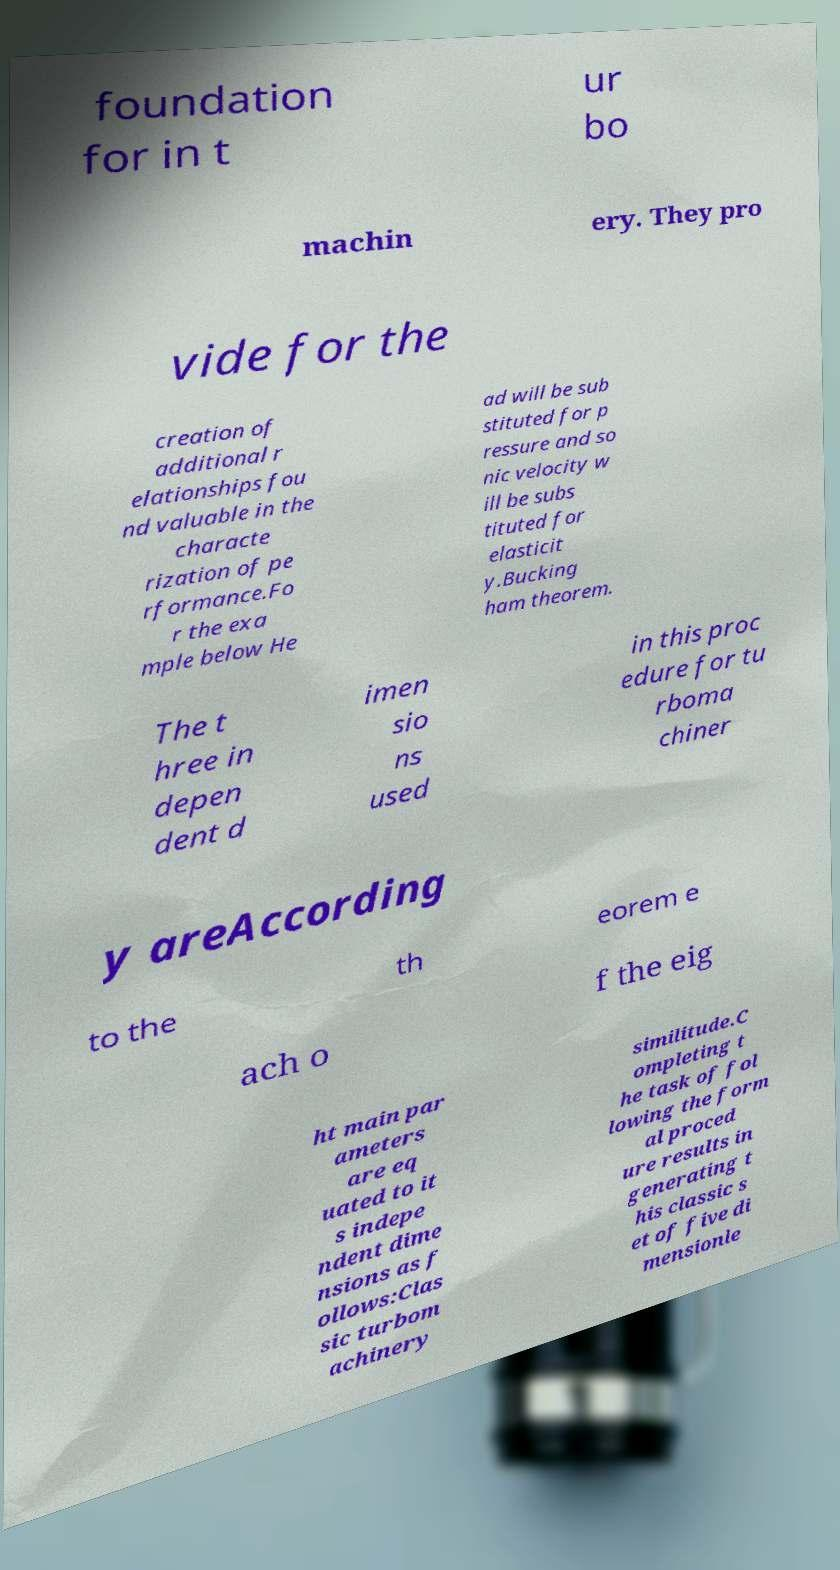Could you extract and type out the text from this image? foundation for in t ur bo machin ery. They pro vide for the creation of additional r elationships fou nd valuable in the characte rization of pe rformance.Fo r the exa mple below He ad will be sub stituted for p ressure and so nic velocity w ill be subs tituted for elasticit y.Bucking ham theorem. The t hree in depen dent d imen sio ns used in this proc edure for tu rboma chiner y areAccording to the th eorem e ach o f the eig ht main par ameters are eq uated to it s indepe ndent dime nsions as f ollows:Clas sic turbom achinery similitude.C ompleting t he task of fol lowing the form al proced ure results in generating t his classic s et of five di mensionle 